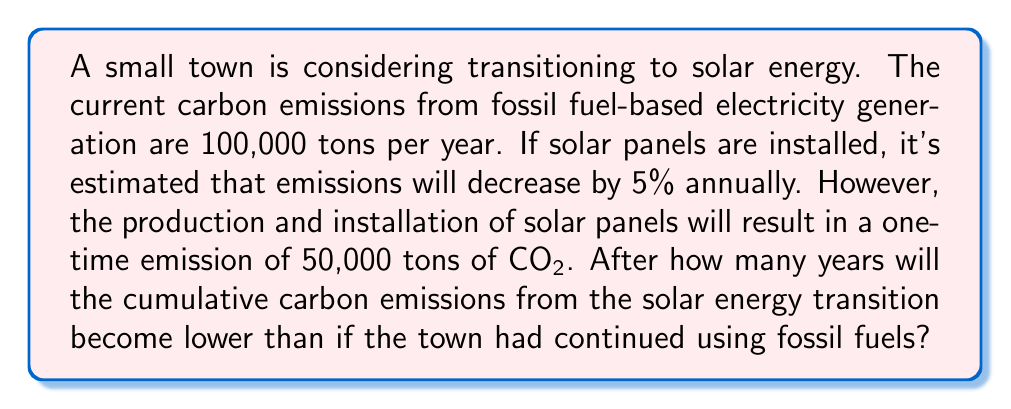Give your solution to this math problem. Let's approach this step-by-step:

1) First, let's define our variables:
   $t$ = number of years
   $E_f(t)$ = cumulative emissions from fossil fuels after $t$ years
   $E_s(t)$ = cumulative emissions from solar transition after $t$ years

2) For fossil fuels, the emissions increase linearly:
   $E_f(t) = 100,000t$

3) For solar, we start with 50,000 tons from installation, then each year the emissions are 95% of the previous year:
   $E_s(t) = 50,000 + 100,000 \sum_{i=1}^t 0.95^{i-1}$

4) This is a geometric series with first term $a=100,000$ and common ratio $r=0.95$. The sum of this series is:
   $S_n = a\frac{1-r^n}{1-r}$ where $n=t$

5) So our solar emissions function becomes:
   $E_s(t) = 50,000 + 100,000 \frac{1-0.95^t}{1-0.95}$

6) We want to find $t$ where $E_s(t) < E_f(t)$:
   $50,000 + 100,000 \frac{1-0.95^t}{1-0.95} < 100,000t$

7) Simplifying:
   $50,000 + 2,000,000(1-0.95^t) < 100,000t$
   $2,050,000 - 2,000,000(0.95^t) < 100,000t$

8) This equation can't be solved algebraically. We need to use numerical methods or graphing to find the smallest integer $t$ that satisfies this inequality.

9) Using a computer or graphing calculator, we find that the smallest integer $t$ that satisfies this is 11.
Answer: 11 years 